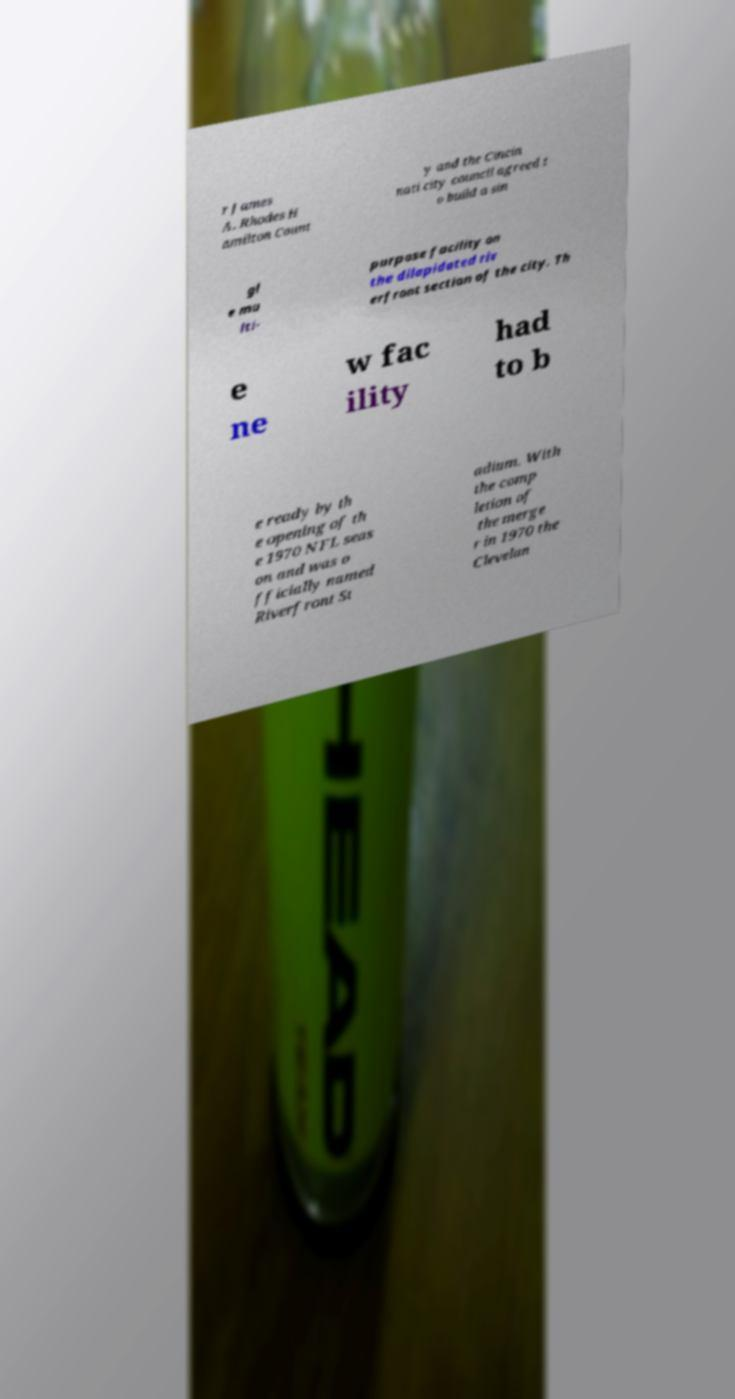Please identify and transcribe the text found in this image. r James A. Rhodes H amilton Count y and the Cincin nati city council agreed t o build a sin gl e mu lti- purpose facility on the dilapidated riv erfront section of the city. Th e ne w fac ility had to b e ready by th e opening of th e 1970 NFL seas on and was o fficially named Riverfront St adium. With the comp letion of the merge r in 1970 the Clevelan 